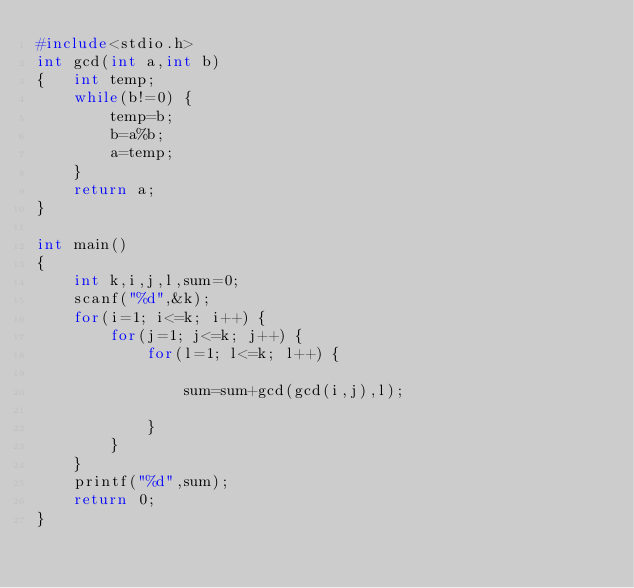<code> <loc_0><loc_0><loc_500><loc_500><_C_>#include<stdio.h>
int gcd(int a,int b)
{   int temp;
    while(b!=0) {
        temp=b;
        b=a%b;
        a=temp;
    }
    return a;
}

int main()
{
    int k,i,j,l,sum=0;
    scanf("%d",&k);
    for(i=1; i<=k; i++) {
        for(j=1; j<=k; j++) {
            for(l=1; l<=k; l++) {

                sum=sum+gcd(gcd(i,j),l);

            }
        }
    }
    printf("%d",sum);
    return 0;
}
</code> 